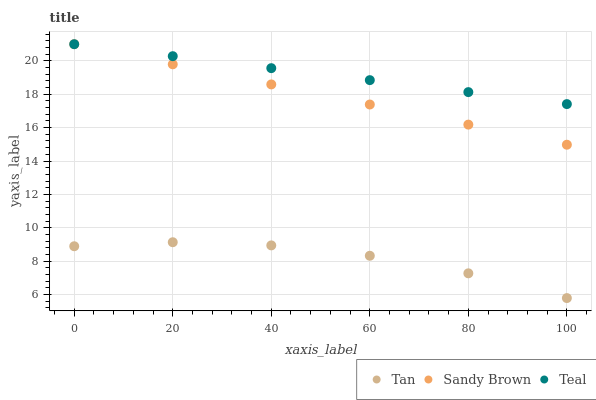Does Tan have the minimum area under the curve?
Answer yes or no. Yes. Does Teal have the maximum area under the curve?
Answer yes or no. Yes. Does Sandy Brown have the minimum area under the curve?
Answer yes or no. No. Does Sandy Brown have the maximum area under the curve?
Answer yes or no. No. Is Teal the smoothest?
Answer yes or no. Yes. Is Tan the roughest?
Answer yes or no. Yes. Is Sandy Brown the smoothest?
Answer yes or no. No. Is Sandy Brown the roughest?
Answer yes or no. No. Does Tan have the lowest value?
Answer yes or no. Yes. Does Sandy Brown have the lowest value?
Answer yes or no. No. Does Teal have the highest value?
Answer yes or no. Yes. Is Tan less than Teal?
Answer yes or no. Yes. Is Sandy Brown greater than Tan?
Answer yes or no. Yes. Does Teal intersect Sandy Brown?
Answer yes or no. Yes. Is Teal less than Sandy Brown?
Answer yes or no. No. Is Teal greater than Sandy Brown?
Answer yes or no. No. Does Tan intersect Teal?
Answer yes or no. No. 